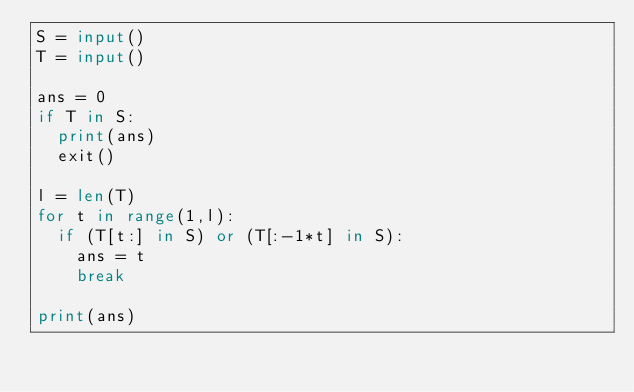<code> <loc_0><loc_0><loc_500><loc_500><_Python_>S = input()
T = input()

ans = 0
if T in S:
  print(ans)
  exit()

l = len(T)
for t in range(1,l):
  if (T[t:] in S) or (T[:-1*t] in S):
    ans = t
    break

print(ans)</code> 